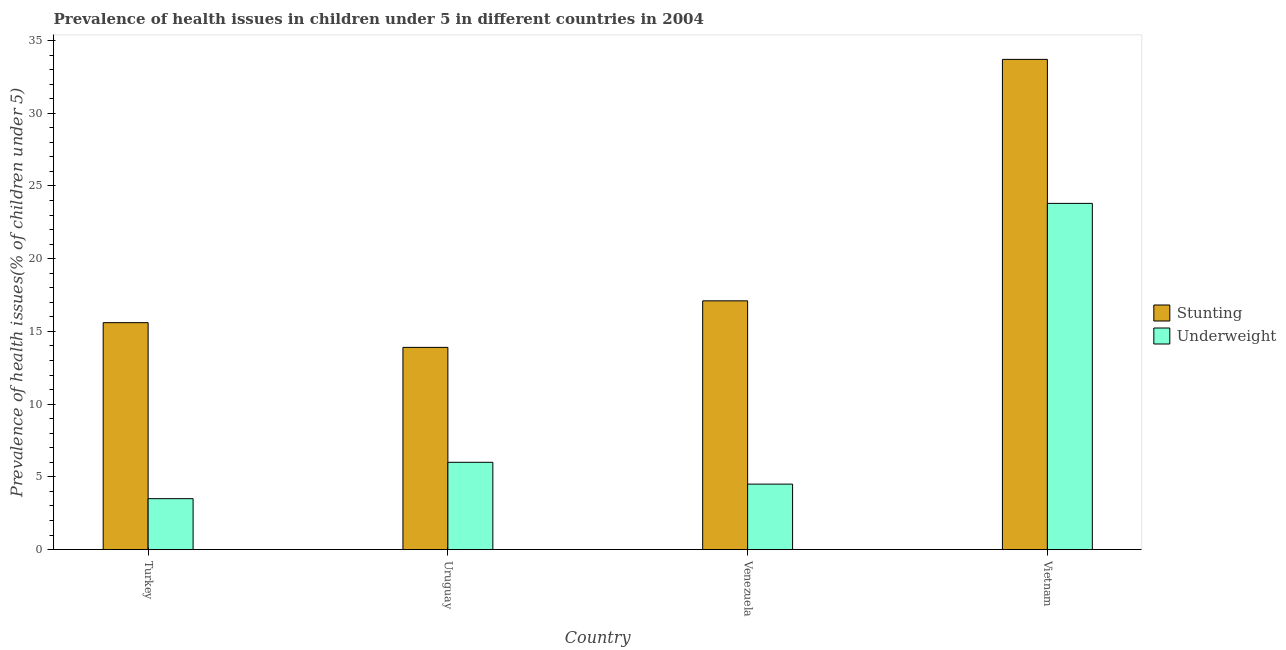Are the number of bars on each tick of the X-axis equal?
Give a very brief answer. Yes. In how many cases, is the number of bars for a given country not equal to the number of legend labels?
Provide a succinct answer. 0. What is the percentage of stunted children in Turkey?
Your answer should be very brief. 15.6. Across all countries, what is the maximum percentage of stunted children?
Your answer should be very brief. 33.7. Across all countries, what is the minimum percentage of stunted children?
Keep it short and to the point. 13.9. In which country was the percentage of underweight children maximum?
Your answer should be compact. Vietnam. In which country was the percentage of stunted children minimum?
Your response must be concise. Uruguay. What is the total percentage of stunted children in the graph?
Your answer should be compact. 80.3. What is the difference between the percentage of underweight children in Turkey and that in Venezuela?
Ensure brevity in your answer.  -1. What is the difference between the percentage of underweight children in Venezuela and the percentage of stunted children in Uruguay?
Offer a terse response. -9.4. What is the average percentage of underweight children per country?
Offer a terse response. 9.45. What is the difference between the percentage of stunted children and percentage of underweight children in Uruguay?
Keep it short and to the point. 7.9. What is the ratio of the percentage of stunted children in Uruguay to that in Vietnam?
Provide a short and direct response. 0.41. Is the percentage of underweight children in Venezuela less than that in Vietnam?
Provide a succinct answer. Yes. Is the difference between the percentage of underweight children in Turkey and Venezuela greater than the difference between the percentage of stunted children in Turkey and Venezuela?
Give a very brief answer. Yes. What is the difference between the highest and the second highest percentage of stunted children?
Ensure brevity in your answer.  16.6. What is the difference between the highest and the lowest percentage of underweight children?
Your answer should be very brief. 20.3. In how many countries, is the percentage of stunted children greater than the average percentage of stunted children taken over all countries?
Provide a succinct answer. 1. What does the 1st bar from the left in Venezuela represents?
Offer a terse response. Stunting. What does the 2nd bar from the right in Vietnam represents?
Offer a terse response. Stunting. How many bars are there?
Offer a very short reply. 8. Are all the bars in the graph horizontal?
Keep it short and to the point. No. How many countries are there in the graph?
Offer a terse response. 4. What is the difference between two consecutive major ticks on the Y-axis?
Offer a terse response. 5. Are the values on the major ticks of Y-axis written in scientific E-notation?
Provide a short and direct response. No. Does the graph contain grids?
Make the answer very short. No. How many legend labels are there?
Your answer should be compact. 2. How are the legend labels stacked?
Give a very brief answer. Vertical. What is the title of the graph?
Offer a terse response. Prevalence of health issues in children under 5 in different countries in 2004. Does "Techinal cooperation" appear as one of the legend labels in the graph?
Provide a succinct answer. No. What is the label or title of the Y-axis?
Provide a succinct answer. Prevalence of health issues(% of children under 5). What is the Prevalence of health issues(% of children under 5) of Stunting in Turkey?
Make the answer very short. 15.6. What is the Prevalence of health issues(% of children under 5) in Underweight in Turkey?
Offer a terse response. 3.5. What is the Prevalence of health issues(% of children under 5) in Stunting in Uruguay?
Make the answer very short. 13.9. What is the Prevalence of health issues(% of children under 5) of Stunting in Venezuela?
Your response must be concise. 17.1. What is the Prevalence of health issues(% of children under 5) of Stunting in Vietnam?
Your answer should be very brief. 33.7. What is the Prevalence of health issues(% of children under 5) in Underweight in Vietnam?
Keep it short and to the point. 23.8. Across all countries, what is the maximum Prevalence of health issues(% of children under 5) in Stunting?
Offer a terse response. 33.7. Across all countries, what is the maximum Prevalence of health issues(% of children under 5) of Underweight?
Keep it short and to the point. 23.8. Across all countries, what is the minimum Prevalence of health issues(% of children under 5) in Stunting?
Ensure brevity in your answer.  13.9. What is the total Prevalence of health issues(% of children under 5) in Stunting in the graph?
Your answer should be very brief. 80.3. What is the total Prevalence of health issues(% of children under 5) of Underweight in the graph?
Your response must be concise. 37.8. What is the difference between the Prevalence of health issues(% of children under 5) of Stunting in Turkey and that in Uruguay?
Keep it short and to the point. 1.7. What is the difference between the Prevalence of health issues(% of children under 5) in Stunting in Turkey and that in Venezuela?
Offer a terse response. -1.5. What is the difference between the Prevalence of health issues(% of children under 5) of Stunting in Turkey and that in Vietnam?
Ensure brevity in your answer.  -18.1. What is the difference between the Prevalence of health issues(% of children under 5) in Underweight in Turkey and that in Vietnam?
Give a very brief answer. -20.3. What is the difference between the Prevalence of health issues(% of children under 5) of Stunting in Uruguay and that in Venezuela?
Your answer should be very brief. -3.2. What is the difference between the Prevalence of health issues(% of children under 5) in Underweight in Uruguay and that in Venezuela?
Your response must be concise. 1.5. What is the difference between the Prevalence of health issues(% of children under 5) in Stunting in Uruguay and that in Vietnam?
Your response must be concise. -19.8. What is the difference between the Prevalence of health issues(% of children under 5) in Underweight in Uruguay and that in Vietnam?
Offer a terse response. -17.8. What is the difference between the Prevalence of health issues(% of children under 5) of Stunting in Venezuela and that in Vietnam?
Provide a succinct answer. -16.6. What is the difference between the Prevalence of health issues(% of children under 5) in Underweight in Venezuela and that in Vietnam?
Give a very brief answer. -19.3. What is the difference between the Prevalence of health issues(% of children under 5) of Stunting in Uruguay and the Prevalence of health issues(% of children under 5) of Underweight in Vietnam?
Your answer should be compact. -9.9. What is the average Prevalence of health issues(% of children under 5) of Stunting per country?
Make the answer very short. 20.07. What is the average Prevalence of health issues(% of children under 5) of Underweight per country?
Give a very brief answer. 9.45. What is the difference between the Prevalence of health issues(% of children under 5) in Stunting and Prevalence of health issues(% of children under 5) in Underweight in Uruguay?
Make the answer very short. 7.9. What is the difference between the Prevalence of health issues(% of children under 5) in Stunting and Prevalence of health issues(% of children under 5) in Underweight in Vietnam?
Provide a succinct answer. 9.9. What is the ratio of the Prevalence of health issues(% of children under 5) in Stunting in Turkey to that in Uruguay?
Offer a terse response. 1.12. What is the ratio of the Prevalence of health issues(% of children under 5) of Underweight in Turkey to that in Uruguay?
Provide a short and direct response. 0.58. What is the ratio of the Prevalence of health issues(% of children under 5) of Stunting in Turkey to that in Venezuela?
Your response must be concise. 0.91. What is the ratio of the Prevalence of health issues(% of children under 5) of Stunting in Turkey to that in Vietnam?
Give a very brief answer. 0.46. What is the ratio of the Prevalence of health issues(% of children under 5) in Underweight in Turkey to that in Vietnam?
Offer a very short reply. 0.15. What is the ratio of the Prevalence of health issues(% of children under 5) of Stunting in Uruguay to that in Venezuela?
Offer a very short reply. 0.81. What is the ratio of the Prevalence of health issues(% of children under 5) of Underweight in Uruguay to that in Venezuela?
Ensure brevity in your answer.  1.33. What is the ratio of the Prevalence of health issues(% of children under 5) in Stunting in Uruguay to that in Vietnam?
Offer a very short reply. 0.41. What is the ratio of the Prevalence of health issues(% of children under 5) in Underweight in Uruguay to that in Vietnam?
Provide a short and direct response. 0.25. What is the ratio of the Prevalence of health issues(% of children under 5) in Stunting in Venezuela to that in Vietnam?
Make the answer very short. 0.51. What is the ratio of the Prevalence of health issues(% of children under 5) in Underweight in Venezuela to that in Vietnam?
Keep it short and to the point. 0.19. What is the difference between the highest and the lowest Prevalence of health issues(% of children under 5) of Stunting?
Your response must be concise. 19.8. What is the difference between the highest and the lowest Prevalence of health issues(% of children under 5) of Underweight?
Offer a terse response. 20.3. 